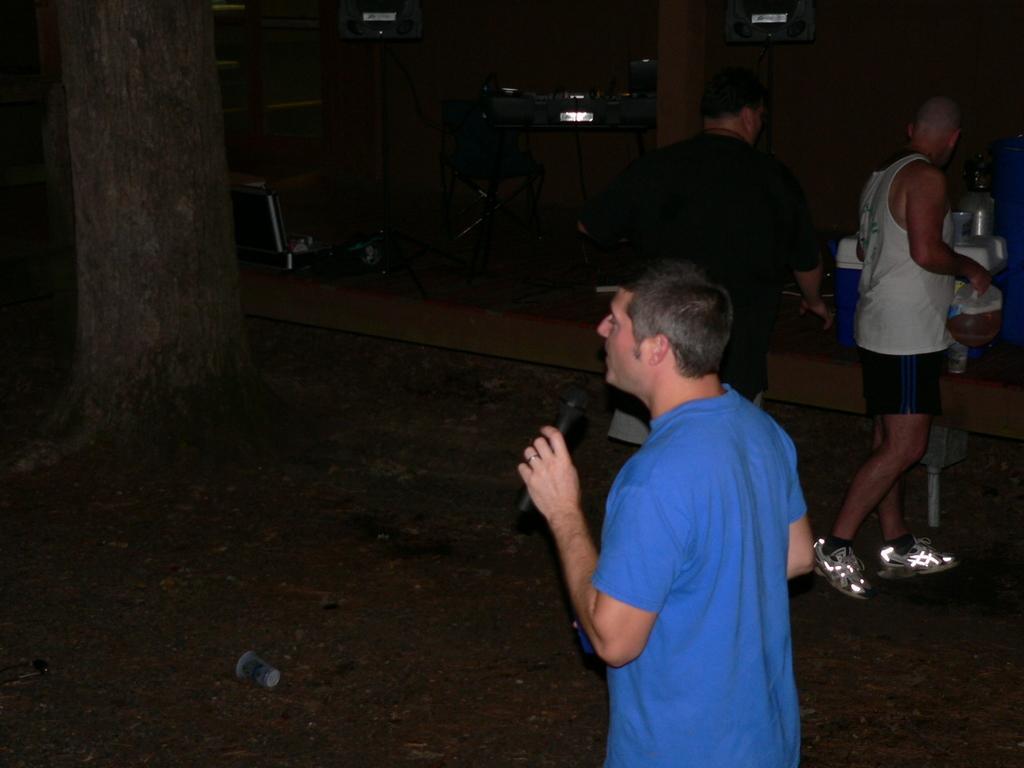In one or two sentences, can you explain what this image depicts? In this image I see 3 men in which this man is wearing blue color t-shirt and I see that he is holding a mic and I see the ground and I see a chair over here and I see a tree and I see few equipment in the background and I see that it is a bit dark over here. 